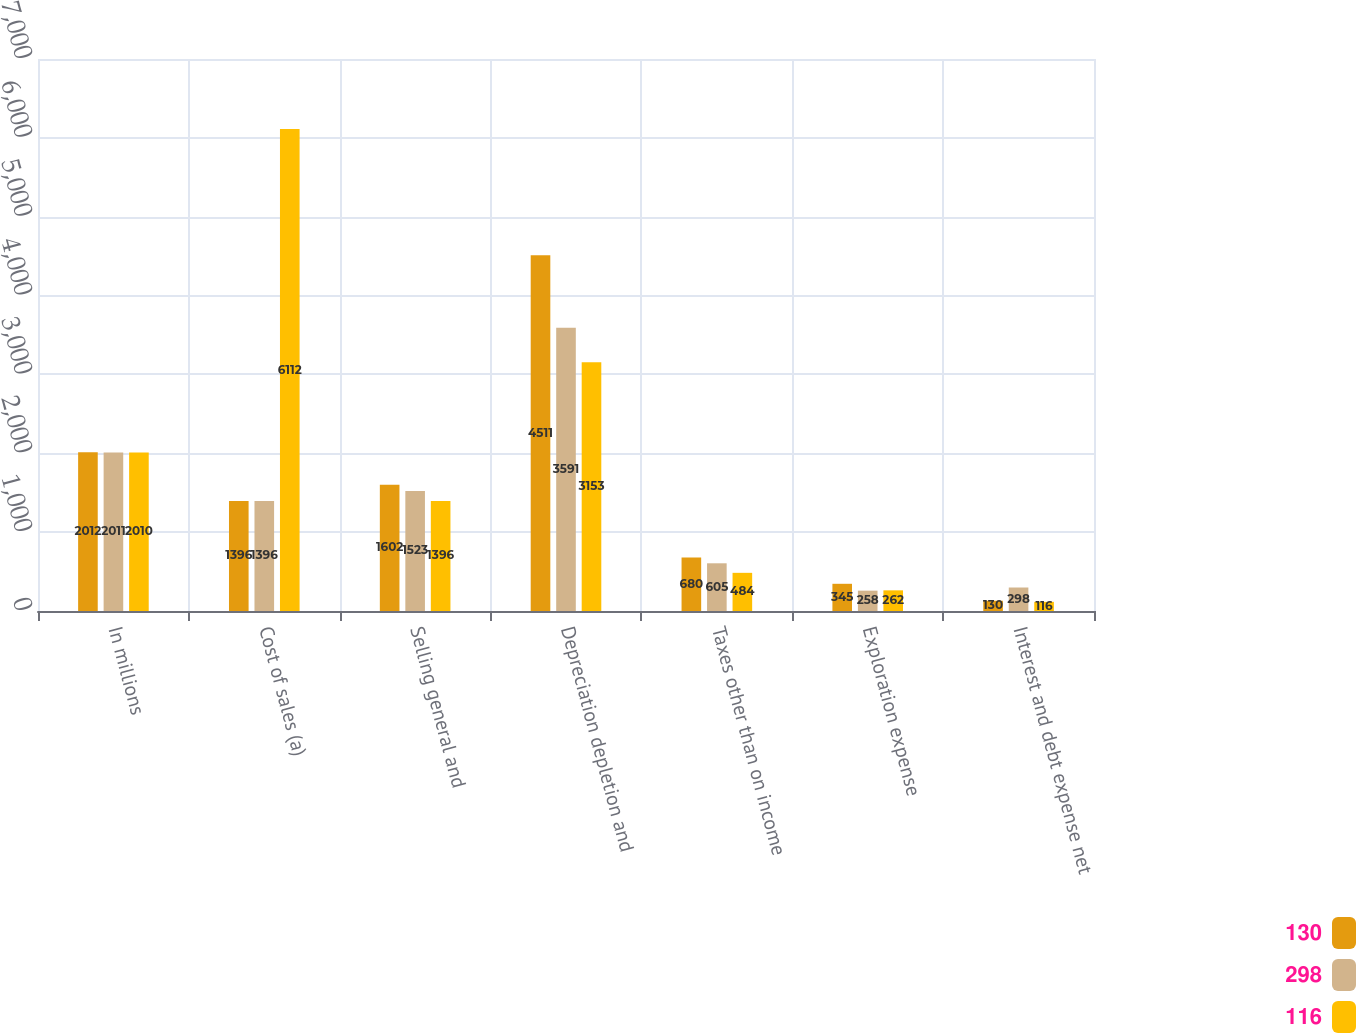Convert chart to OTSL. <chart><loc_0><loc_0><loc_500><loc_500><stacked_bar_chart><ecel><fcel>In millions<fcel>Cost of sales (a)<fcel>Selling general and<fcel>Depreciation depletion and<fcel>Taxes other than on income<fcel>Exploration expense<fcel>Interest and debt expense net<nl><fcel>130<fcel>2012<fcel>1396<fcel>1602<fcel>4511<fcel>680<fcel>345<fcel>130<nl><fcel>298<fcel>2011<fcel>1396<fcel>1523<fcel>3591<fcel>605<fcel>258<fcel>298<nl><fcel>116<fcel>2010<fcel>6112<fcel>1396<fcel>3153<fcel>484<fcel>262<fcel>116<nl></chart> 